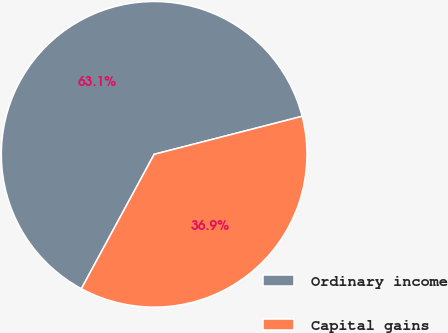<chart> <loc_0><loc_0><loc_500><loc_500><pie_chart><fcel>Ordinary income<fcel>Capital gains<nl><fcel>63.1%<fcel>36.9%<nl></chart> 